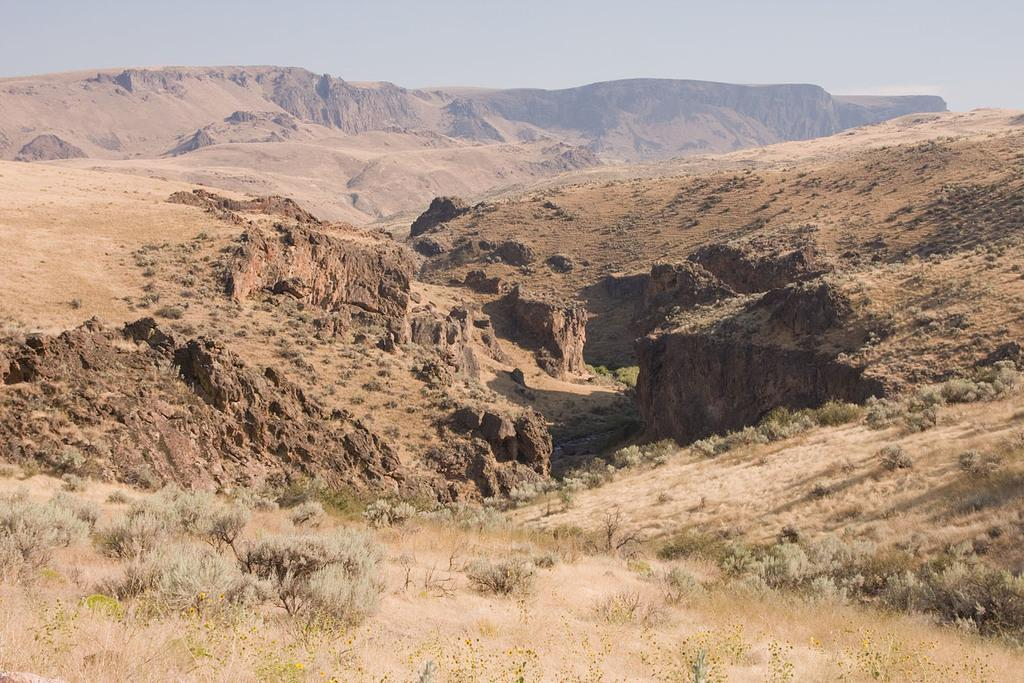What type of vegetation can be seen in the image? There is grass and plants in the image. What type of natural landform is visible in the image? There are mountains in the image. What part of the natural environment is visible in the image? The sky is visible in the image. What type of environment might the image depict? The image may have been taken in a desert land. How does the bomb affect the plants in the image? There is no bomb present in the image, so its effect on the plants cannot be determined. 